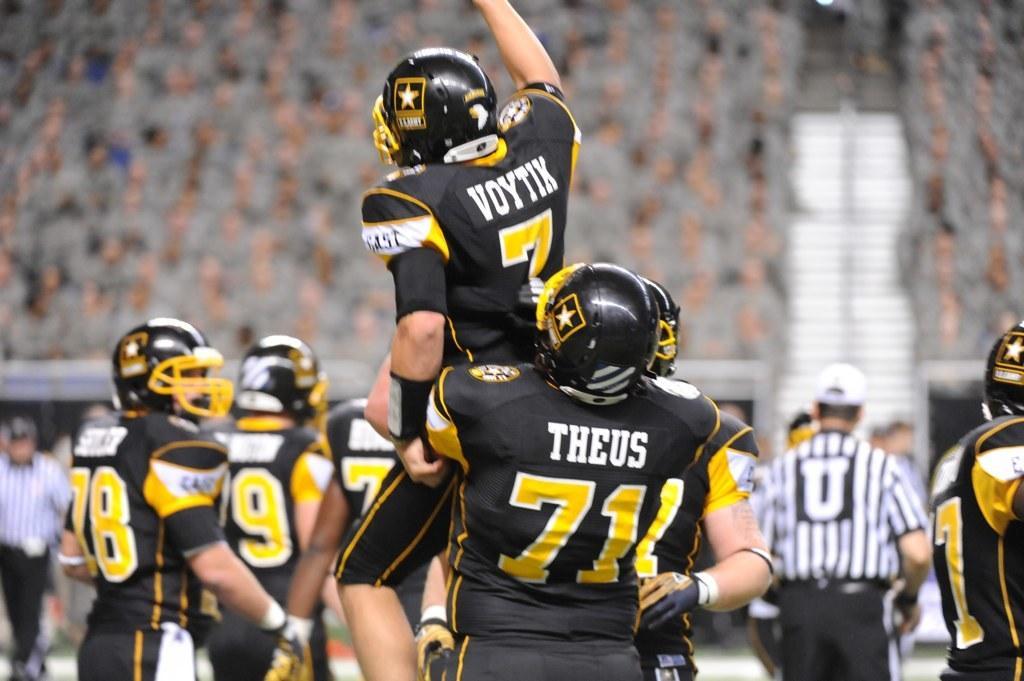Can you describe this image briefly? In this picture we can observe rugby players in the ground. They are wearing black and yellow color dresses. All of them were wearing helmets. We can observe referees in this picture. In the background there are some people sitting in the stands and watching the game. 